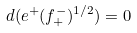Convert formula to latex. <formula><loc_0><loc_0><loc_500><loc_500>d ( e ^ { + } ( f ^ { - } _ { + } ) ^ { 1 / 2 } ) = 0</formula> 